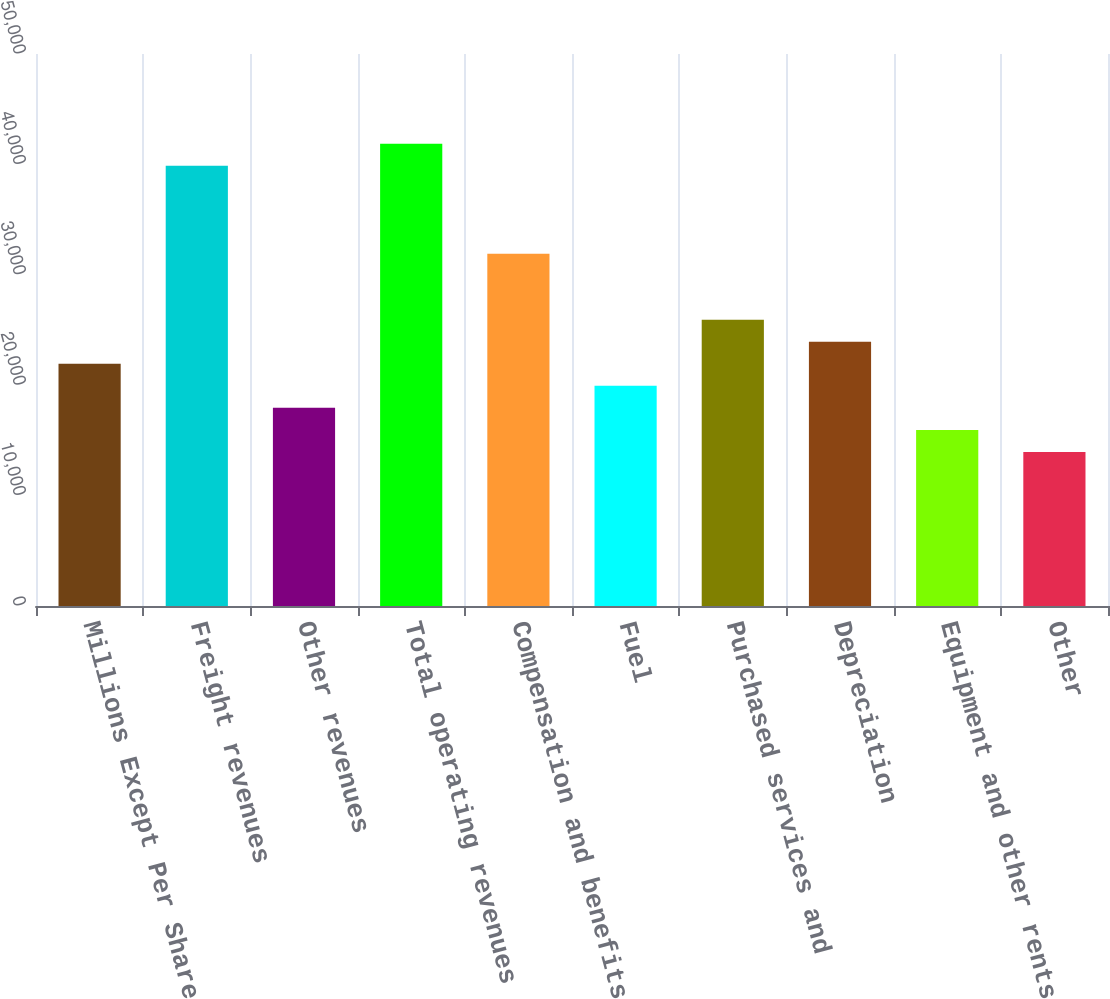Convert chart to OTSL. <chart><loc_0><loc_0><loc_500><loc_500><bar_chart><fcel>Millions Except Per Share<fcel>Freight revenues<fcel>Other revenues<fcel>Total operating revenues<fcel>Compensation and benefits<fcel>Fuel<fcel>Purchased services and<fcel>Depreciation<fcel>Equipment and other rents<fcel>Other<nl><fcel>21934.8<fcel>39879.7<fcel>17947.1<fcel>41873.6<fcel>31904.2<fcel>19941<fcel>25922.6<fcel>23928.7<fcel>15953.2<fcel>13959.4<nl></chart> 